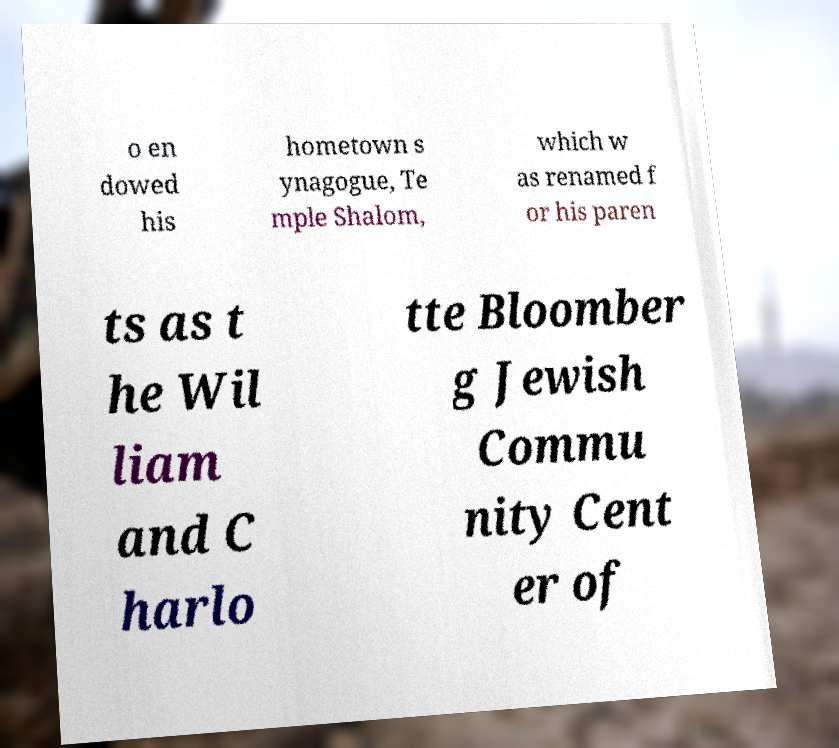Could you assist in decoding the text presented in this image and type it out clearly? o en dowed his hometown s ynagogue, Te mple Shalom, which w as renamed f or his paren ts as t he Wil liam and C harlo tte Bloomber g Jewish Commu nity Cent er of 